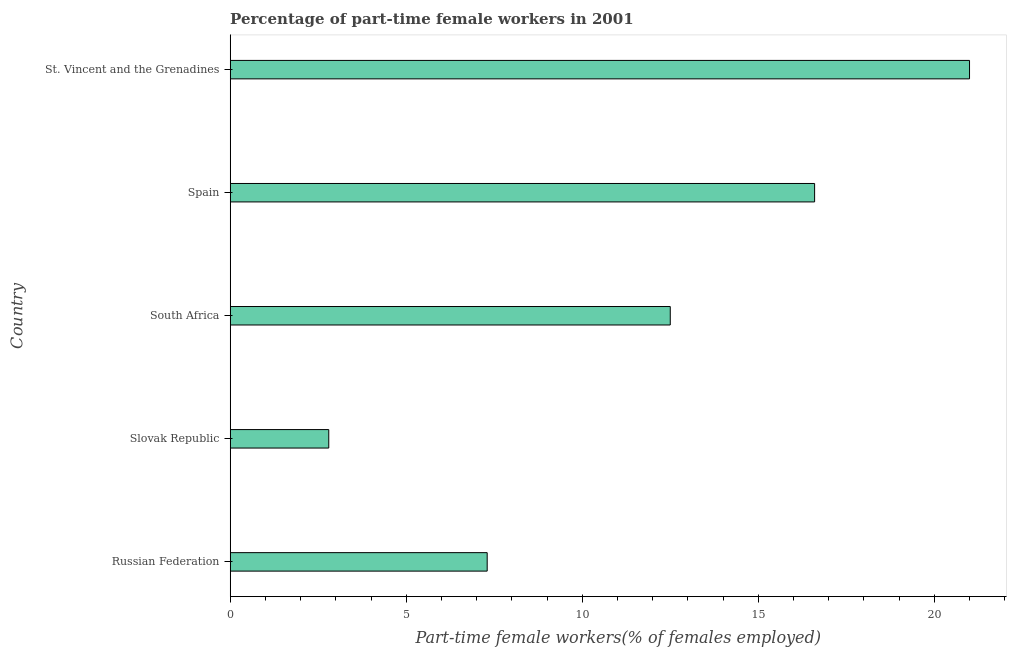Does the graph contain any zero values?
Offer a very short reply. No. What is the title of the graph?
Offer a very short reply. Percentage of part-time female workers in 2001. What is the label or title of the X-axis?
Keep it short and to the point. Part-time female workers(% of females employed). What is the percentage of part-time female workers in Spain?
Provide a succinct answer. 16.6. Across all countries, what is the maximum percentage of part-time female workers?
Your answer should be compact. 21. Across all countries, what is the minimum percentage of part-time female workers?
Ensure brevity in your answer.  2.8. In which country was the percentage of part-time female workers maximum?
Your answer should be compact. St. Vincent and the Grenadines. In which country was the percentage of part-time female workers minimum?
Offer a terse response. Slovak Republic. What is the sum of the percentage of part-time female workers?
Ensure brevity in your answer.  60.2. What is the difference between the percentage of part-time female workers in Russian Federation and St. Vincent and the Grenadines?
Make the answer very short. -13.7. What is the average percentage of part-time female workers per country?
Your answer should be compact. 12.04. What is the median percentage of part-time female workers?
Your response must be concise. 12.5. In how many countries, is the percentage of part-time female workers greater than 20 %?
Ensure brevity in your answer.  1. What is the ratio of the percentage of part-time female workers in Spain to that in St. Vincent and the Grenadines?
Offer a very short reply. 0.79. What is the difference between the highest and the second highest percentage of part-time female workers?
Give a very brief answer. 4.4. How many bars are there?
Provide a short and direct response. 5. How many countries are there in the graph?
Your answer should be compact. 5. Are the values on the major ticks of X-axis written in scientific E-notation?
Your response must be concise. No. What is the Part-time female workers(% of females employed) in Russian Federation?
Give a very brief answer. 7.3. What is the Part-time female workers(% of females employed) in Slovak Republic?
Offer a very short reply. 2.8. What is the Part-time female workers(% of females employed) in Spain?
Offer a terse response. 16.6. What is the difference between the Part-time female workers(% of females employed) in Russian Federation and South Africa?
Offer a terse response. -5.2. What is the difference between the Part-time female workers(% of females employed) in Russian Federation and St. Vincent and the Grenadines?
Your answer should be very brief. -13.7. What is the difference between the Part-time female workers(% of females employed) in Slovak Republic and Spain?
Offer a very short reply. -13.8. What is the difference between the Part-time female workers(% of females employed) in Slovak Republic and St. Vincent and the Grenadines?
Offer a terse response. -18.2. What is the difference between the Part-time female workers(% of females employed) in South Africa and Spain?
Your answer should be compact. -4.1. What is the ratio of the Part-time female workers(% of females employed) in Russian Federation to that in Slovak Republic?
Ensure brevity in your answer.  2.61. What is the ratio of the Part-time female workers(% of females employed) in Russian Federation to that in South Africa?
Offer a terse response. 0.58. What is the ratio of the Part-time female workers(% of females employed) in Russian Federation to that in Spain?
Ensure brevity in your answer.  0.44. What is the ratio of the Part-time female workers(% of females employed) in Russian Federation to that in St. Vincent and the Grenadines?
Offer a terse response. 0.35. What is the ratio of the Part-time female workers(% of females employed) in Slovak Republic to that in South Africa?
Offer a terse response. 0.22. What is the ratio of the Part-time female workers(% of females employed) in Slovak Republic to that in Spain?
Your answer should be compact. 0.17. What is the ratio of the Part-time female workers(% of females employed) in Slovak Republic to that in St. Vincent and the Grenadines?
Provide a succinct answer. 0.13. What is the ratio of the Part-time female workers(% of females employed) in South Africa to that in Spain?
Your response must be concise. 0.75. What is the ratio of the Part-time female workers(% of females employed) in South Africa to that in St. Vincent and the Grenadines?
Provide a short and direct response. 0.59. What is the ratio of the Part-time female workers(% of females employed) in Spain to that in St. Vincent and the Grenadines?
Provide a short and direct response. 0.79. 